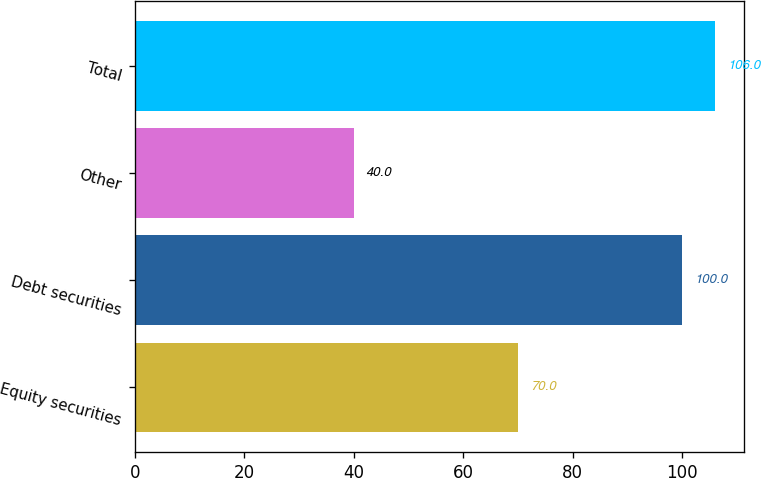Convert chart to OTSL. <chart><loc_0><loc_0><loc_500><loc_500><bar_chart><fcel>Equity securities<fcel>Debt securities<fcel>Other<fcel>Total<nl><fcel>70<fcel>100<fcel>40<fcel>106<nl></chart> 